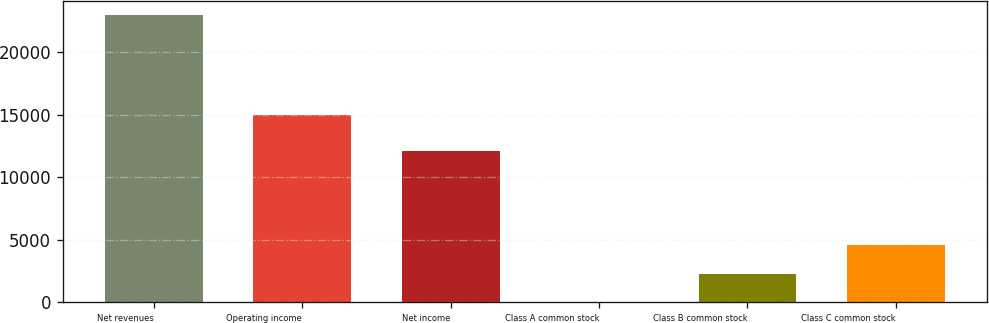Convert chart. <chart><loc_0><loc_0><loc_500><loc_500><bar_chart><fcel>Net revenues<fcel>Operating income<fcel>Net income<fcel>Class A common stock<fcel>Class B common stock<fcel>Class C common stock<nl><fcel>22977<fcel>15001<fcel>12080<fcel>5.32<fcel>2302.49<fcel>4599.66<nl></chart> 